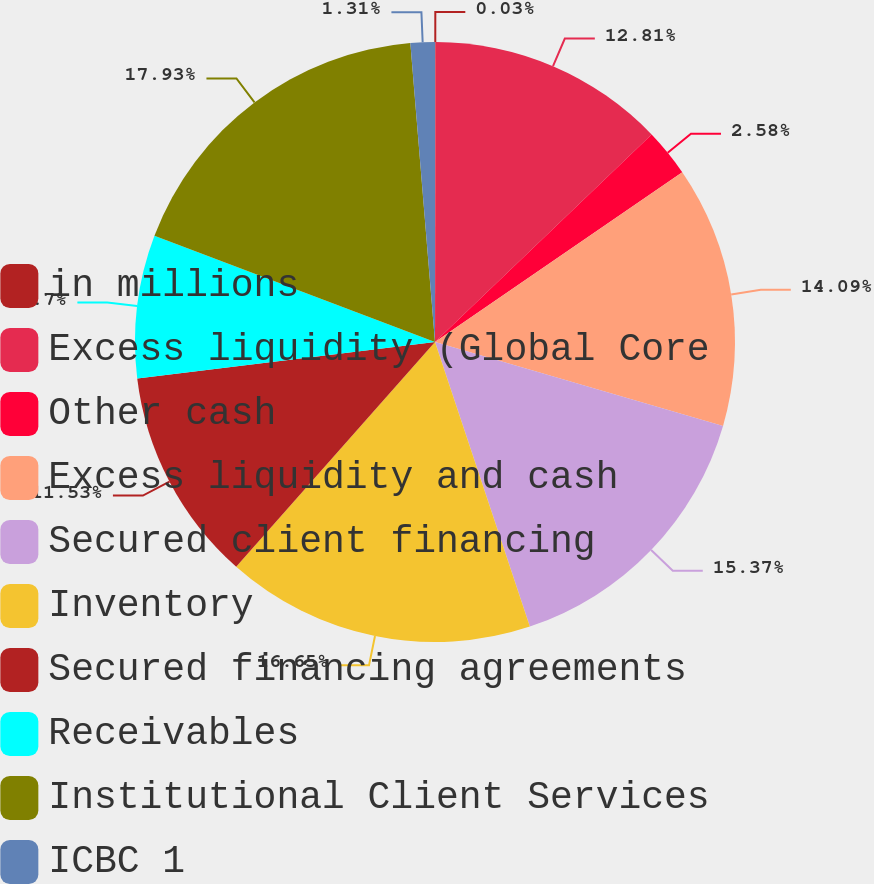Convert chart to OTSL. <chart><loc_0><loc_0><loc_500><loc_500><pie_chart><fcel>in millions<fcel>Excess liquidity (Global Core<fcel>Other cash<fcel>Excess liquidity and cash<fcel>Secured client financing<fcel>Inventory<fcel>Secured financing agreements<fcel>Receivables<fcel>Institutional Client Services<fcel>ICBC 1<nl><fcel>0.03%<fcel>12.81%<fcel>2.58%<fcel>14.09%<fcel>15.37%<fcel>16.65%<fcel>11.53%<fcel>7.7%<fcel>17.93%<fcel>1.31%<nl></chart> 